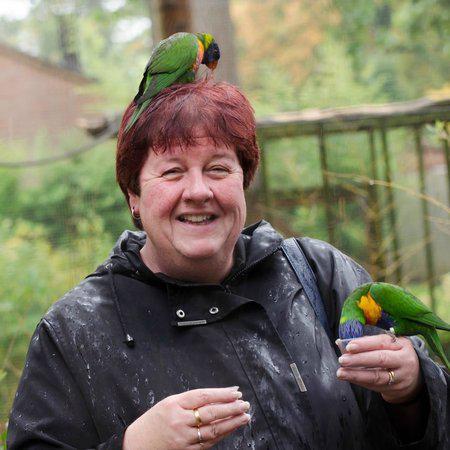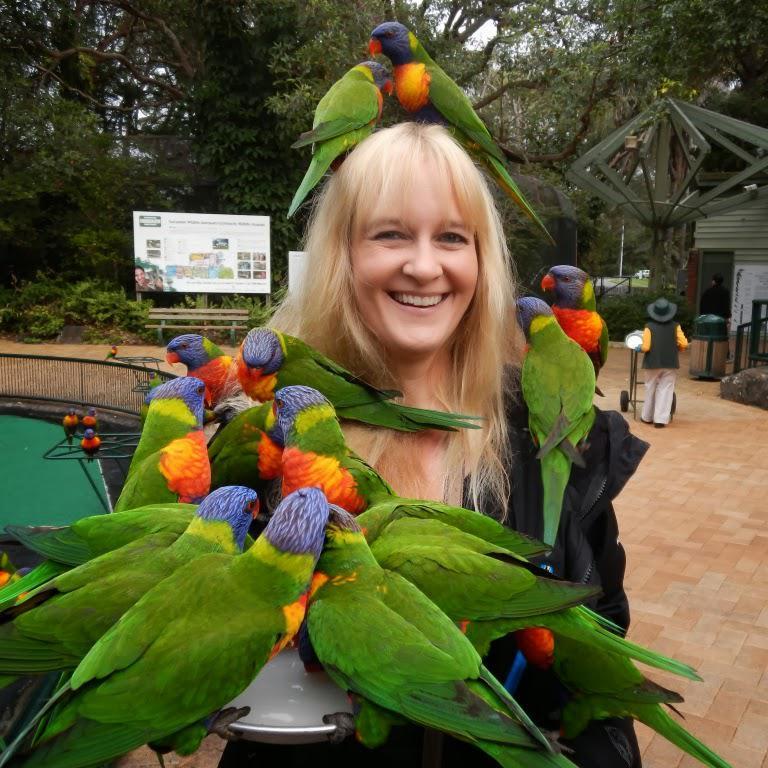The first image is the image on the left, the second image is the image on the right. Analyze the images presented: Is the assertion "One smiling woman who is not wearing a hat has exactly one green bird perched on her head." valid? Answer yes or no. Yes. The first image is the image on the left, the second image is the image on the right. Evaluate the accuracy of this statement regarding the images: "An image shows a person with more than one parrot atop her head.". Is it true? Answer yes or no. Yes. 